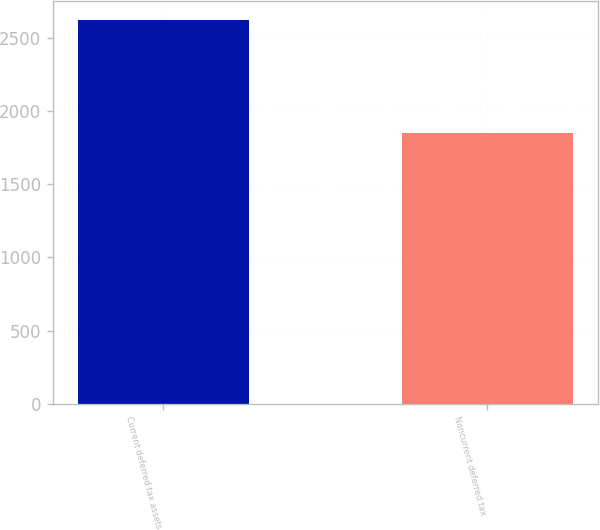<chart> <loc_0><loc_0><loc_500><loc_500><bar_chart><fcel>Current deferred tax assets<fcel>Noncurrent deferred tax<nl><fcel>2619<fcel>1848<nl></chart> 